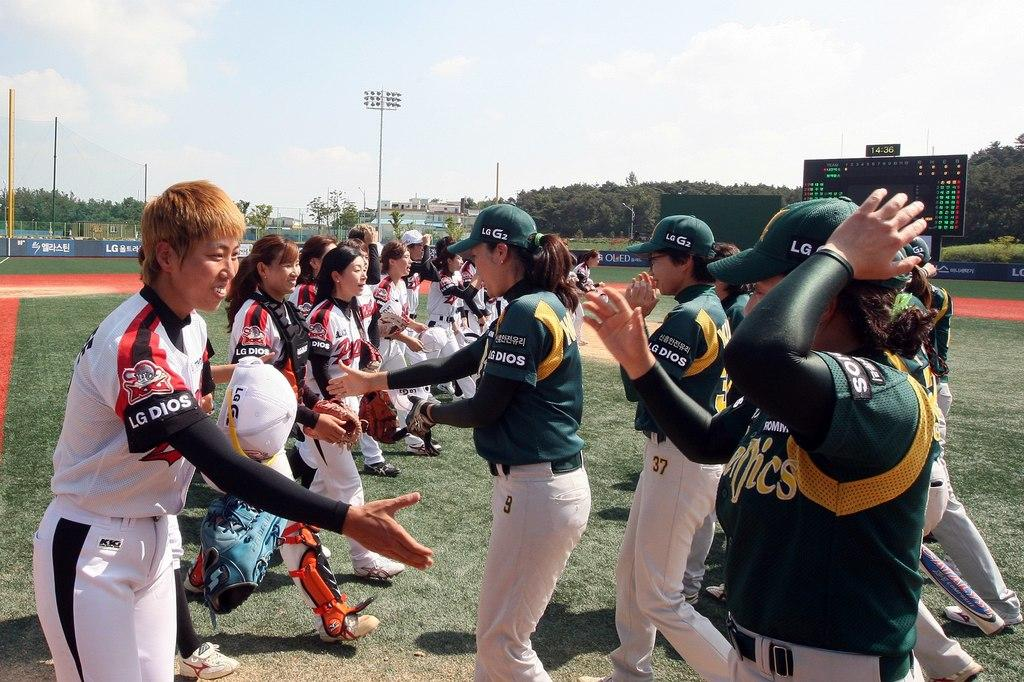<image>
Provide a brief description of the given image. Two teams of women sports team on the field both wearing jersey with marking of LG DIOS. 